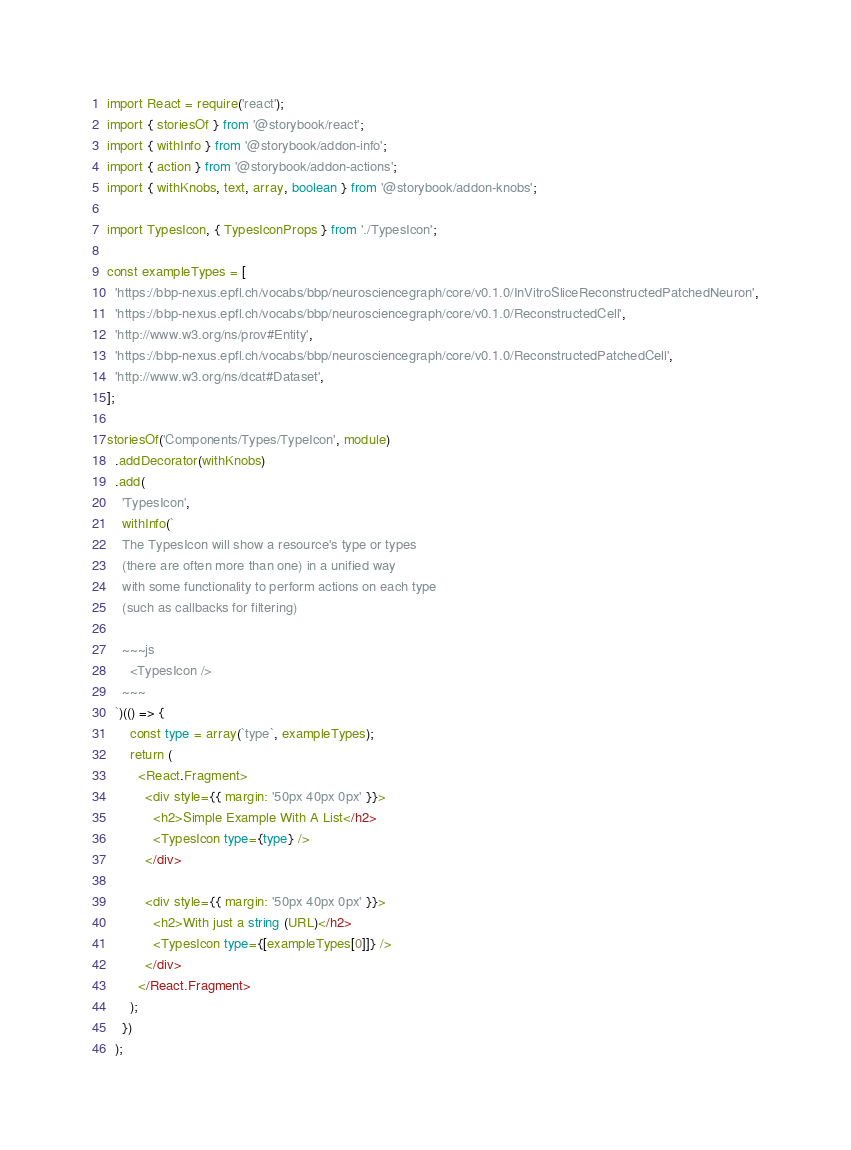Convert code to text. <code><loc_0><loc_0><loc_500><loc_500><_TypeScript_>import React = require('react');
import { storiesOf } from '@storybook/react';
import { withInfo } from '@storybook/addon-info';
import { action } from '@storybook/addon-actions';
import { withKnobs, text, array, boolean } from '@storybook/addon-knobs';

import TypesIcon, { TypesIconProps } from './TypesIcon';

const exampleTypes = [
  'https://bbp-nexus.epfl.ch/vocabs/bbp/neurosciencegraph/core/v0.1.0/InVitroSliceReconstructedPatchedNeuron',
  'https://bbp-nexus.epfl.ch/vocabs/bbp/neurosciencegraph/core/v0.1.0/ReconstructedCell',
  'http://www.w3.org/ns/prov#Entity',
  'https://bbp-nexus.epfl.ch/vocabs/bbp/neurosciencegraph/core/v0.1.0/ReconstructedPatchedCell',
  'http://www.w3.org/ns/dcat#Dataset',
];

storiesOf('Components/Types/TypeIcon', module)
  .addDecorator(withKnobs)
  .add(
    'TypesIcon',
    withInfo(`
    The TypesIcon will show a resource's type or types
    (there are often more than one) in a unified way
    with some functionality to perform actions on each type
    (such as callbacks for filtering)

    ~~~js
      <TypesIcon />
    ~~~
  `)(() => {
      const type = array(`type`, exampleTypes);
      return (
        <React.Fragment>
          <div style={{ margin: '50px 40px 0px' }}>
            <h2>Simple Example With A List</h2>
            <TypesIcon type={type} />
          </div>

          <div style={{ margin: '50px 40px 0px' }}>
            <h2>With just a string (URL)</h2>
            <TypesIcon type={[exampleTypes[0]]} />
          </div>
        </React.Fragment>
      );
    })
  );
</code> 